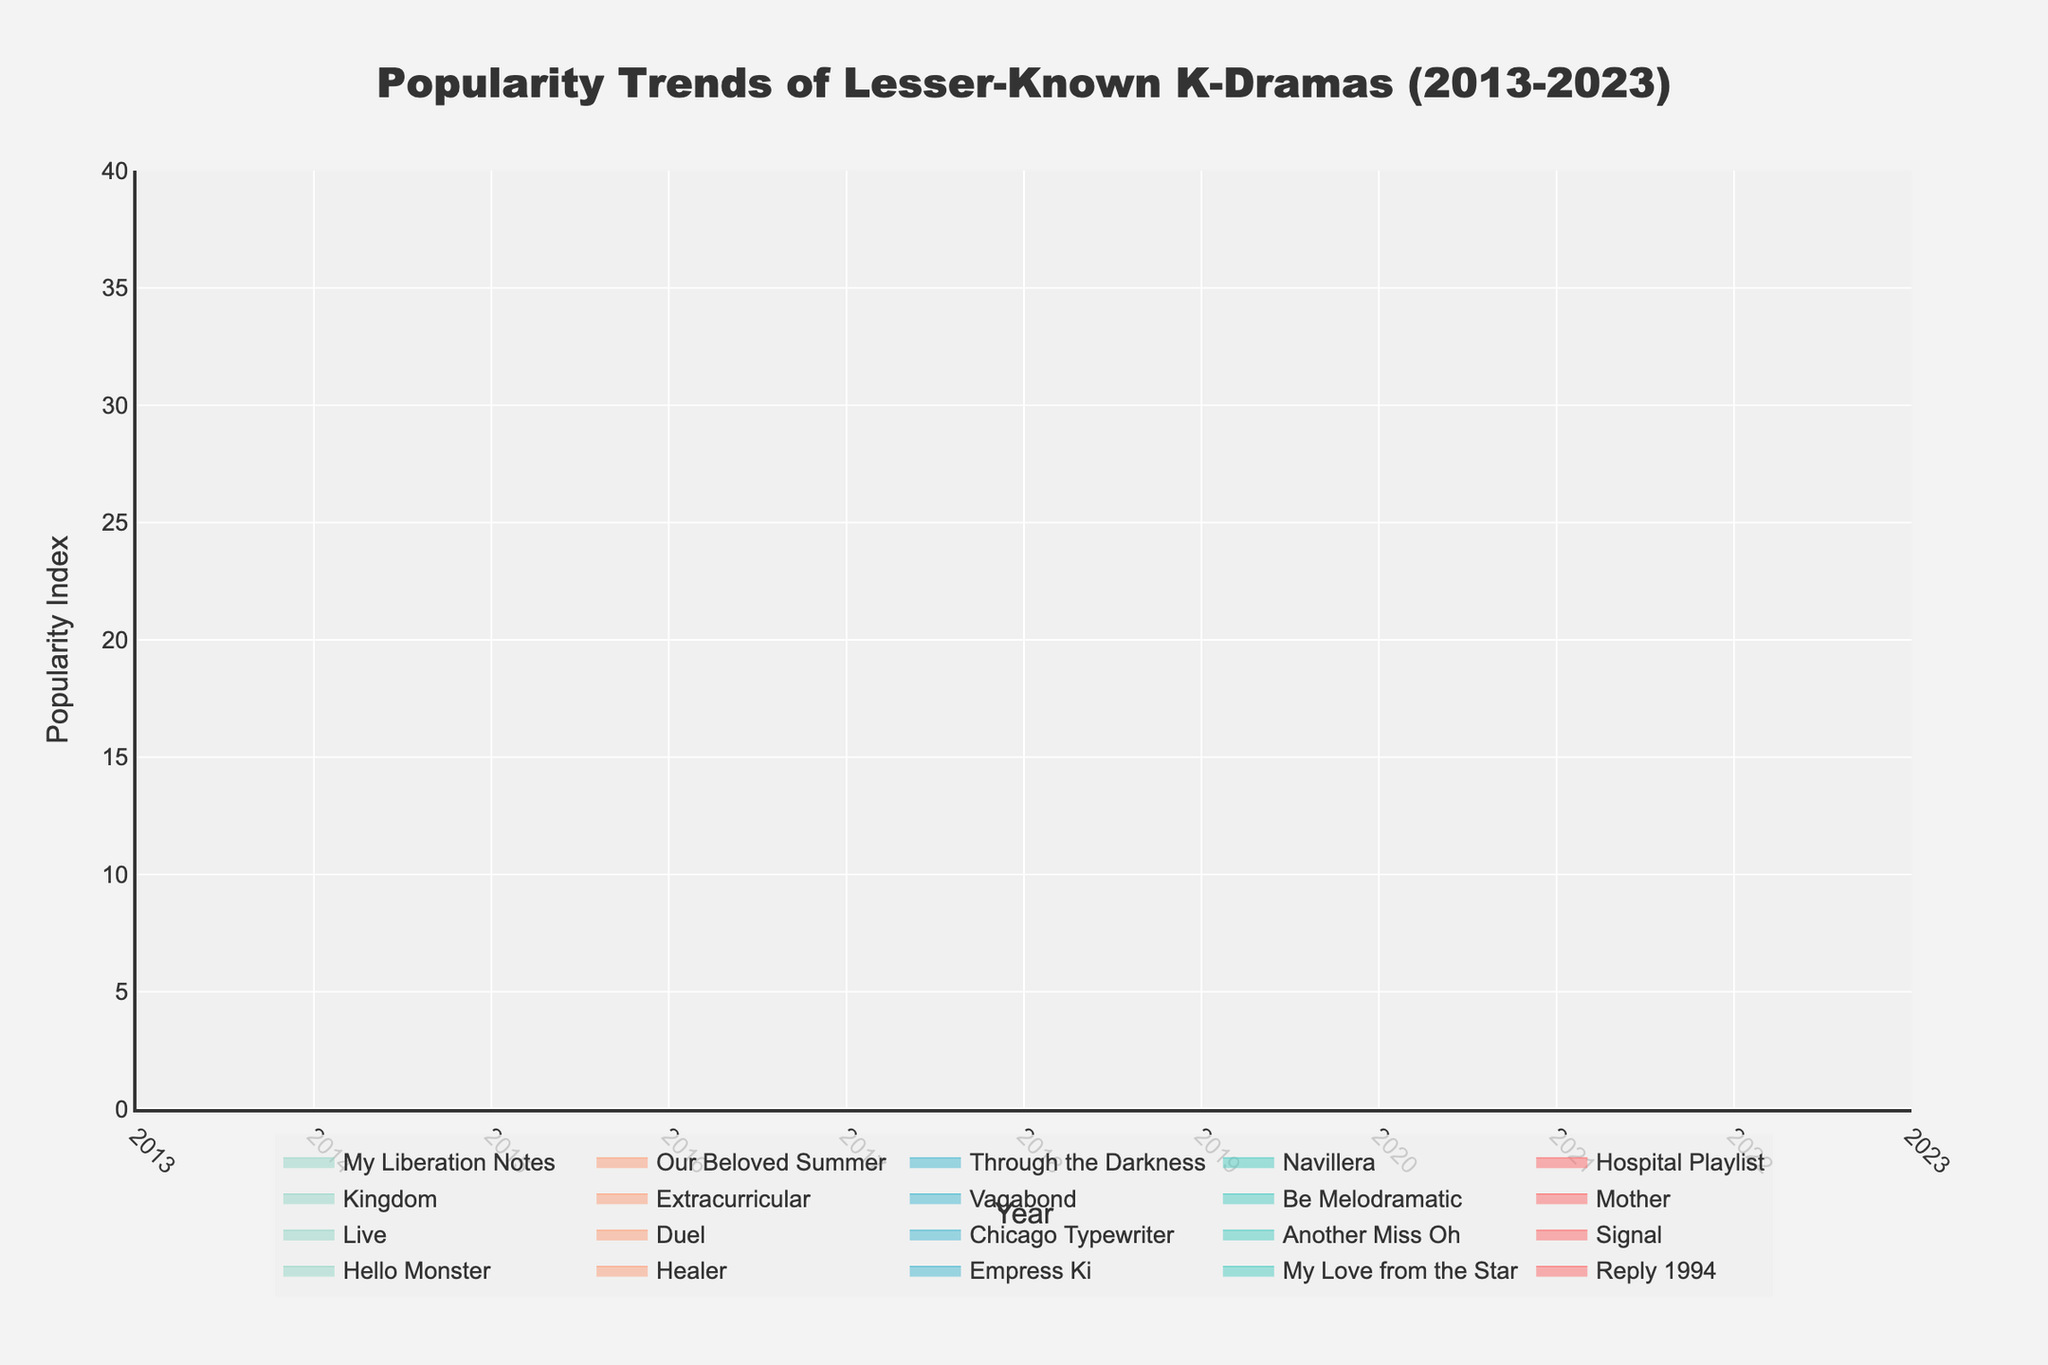What is the title of the plot? The title of the plot can be found at the top of the figure. It reads "Popularity Trends of Lesser-Known K-Dramas (2013-2023)"
Answer: Popularity Trends of Lesser-Known K-Dramas (2013-2023) What is the highest Popularity Index value shown on the y-axis? The y-axis on the right side of the plot shows the range of Popularity Index values, and the highest value is 35.
Answer: 35 How many K-Dramas experienced a popularity index of 30 or higher? By observing the different lines in the figure, "My Love from the Star," "Kingdom," and "Hospital Playlist" each have a popularity index of 30 or higher.
Answer: 3 Which year saw the highest number of K-Dramas plotted? By inspecting the x-axis and the number of distinct lines per year, 2022 has the most K-Dramas with two entries: "Through the Darkness" and "Our Beloved Summer."
Answer: 2022 Compare the popularity indices of "Reply 1994" and "Duel." "Reply 1994" has a popularity index of 15, while "Duel" has a popularity index of 13, meaning "Reply 1994" is more popular by 2 points.
Answer: Reply 1994 is more popular by 2 points What is the average Popularity Index of K-Dramas released in 2016? The K-Dramas from 2016 include "Signal" with an index of 22 and "Another Miss Oh" with an index of 16. Sum these indices, which is 22 + 16 = 38, and divide by 2.
Answer: 19 Which K-Drama experienced the highest increase in Popularity Index from one year to the next listed in the data? "My Love from the Star" in 2014 has a Popularity Index of 30, while 2013's "Reply 1994" has 15. The increase is 30 - 15 = 15, which is the highest jump.
Answer: My Love from the Star Among the K-Dramas listed in 2019, which one has a higher Popularity Index? The K-Dramas listed in 2019 are "Be Melodramatic" with an index of 23 and "Vagabond" with an index of 20. "Be Melodramatic" is higher.
Answer: Be Melodramatic What is the Popularity Index range of K-Dramas released in 2020? By observing the 2020 data points, "Extracurricular" has a Popularity Index of 25, and "Kingdom" has 30. The range is 30 - 25.
Answer: 5 Describe the trend of K-Drama popularity from 2021 to 2023. From 2021, "Hospital Playlist" has a Popularity Index of 35, followed by "Navillera" at 17. In 2022, "Through the Darkness" is 19, and "Our Beloved Summer" is 22. In 2023, "My Liberation Notes" is 27. Overall, there’s a decrease from 2021 to 2022, followed by an increase in 2023.
Answer: Decrease in 2021-2022, increase in 2023 